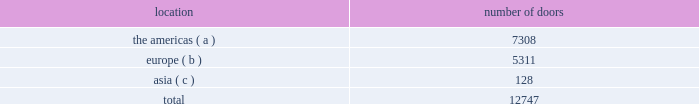Ralph lauren restaurants ralph lauren's restaurants translate mr .
Ralph lauren's distinctive vision into places to gather with family and friends to enjoy fine food .
In 1999 , the first rl restaurant opened , adjacent to the ralph lauren chicago store on michigan avenue .
This restaurant exemplifies the timeless design sensibility of ralph lauren's world and features classic american "city club" cuisine .
In 2010 , ralph's was opened in the courtyard and converted stables of our paris store on the blvd .
Saint germain .
Ralph's presents mr .
Lauren's favorite american classics in an elegant and glamorous french environment .
In august 2014 , we opened ralph's coffee on the second floor of our polo flagship store in new york city , featuring private custom coffee roasts , sandwiches , and sweet treats .
The polo bar , adjacent to our new york city polo flagship store , opened in january 2015 with a menu dedicated to serving seasonal american classics in a setting that pays homage to the sophisticated equestrian heritage of the ralph lauren world .
Our wholesale segment our wholesale segment sells our products globally to leading upscale and certain mid-tier department stores , specialty stores , and golf and pro shops .
We have continued to focus on elevating our brand by improving in-store product assortment and presentation , as well as full-price sell-throughs to consumers .
As of the end of fiscal 2015 , our wholesale products were sold through approximately 13000 doors worldwide and we invested $ 48 million of capital in related shop-within-shops during fiscal 2015 , primarily in domestic and international department and specialty stores .
Our products are also sold through the e-commerce sites of certain of our wholesale customers .
The primary product offerings sold through our wholesale channels of distribution include apparel , accessories , and home furnishings .
Our collection brands 2014 ralph lauren women's collection and black label and men's purple label and black label 2014 are distributed worldwide through a limited number of premier fashion retailers .
Department stores are our major wholesale customers in north america .
In latin america , our wholesale products are sold in department stores and specialty stores .
In europe , our wholesale sales are comprised of a varying mix of sales to both department stores and specialty stores , depending on the country .
In japan , our wholesale products are distributed primarily through shop-within-shops at premier and top-tier department stores .
In the greater china and southeast asia region , australia , and new zealand , our wholesale products are sold mainly at mid and top-tier department stores .
We also distribute our wholesale products to certain licensed stores operated by our partners in latin america , asia , europe , and the middle east .
We sell the majority of our excess and out-of-season products through secondary distribution channels worldwide , including our retail factory stores .
Worldwide wholesale distribution channels the table presents the number of doors by geographic location in which products distributed by our wholesale segment were sold to consumers in our primary channels of distribution as of march 28 , 2015: .
( a ) includes the u.s. , canada , and latin america .
( b ) includes the middle east .
( c ) includes australia and new zealand .
We have three key wholesale customers that generate significant sales volume .
During fiscal 2015 , sales to our largest wholesale customer , macy's , inc .
( "macy's" ) , accounted for approximately 12% ( 12 % ) and 26% ( 26 % ) of our total net revenues and total wholesale net revenues , respectively .
Further , during fiscal 2015 , sales to our three largest wholesale customers , including macy's , accounted for approximately 24% ( 24 % ) and 52% ( 52 % ) of our total net revenues and total wholesale net revenues , respectively. .
What percentage of the wholesale segment doors as of march 28 , 2015 where located in asia? 
Computations: (128 / 12747)
Answer: 0.01004. 